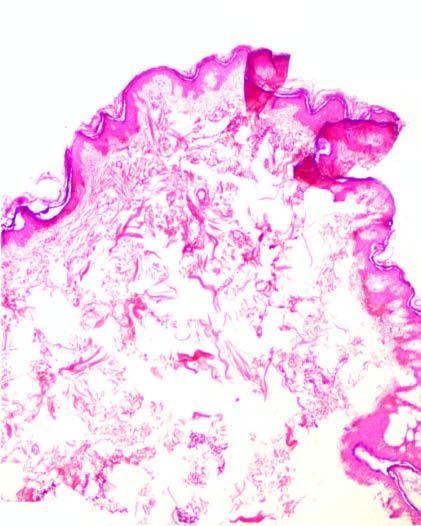what is raised as polypoid mass over dense hyalinised fibrous connective tissue in the dermis?
Answer the question using a single word or phrase. Epidermis 